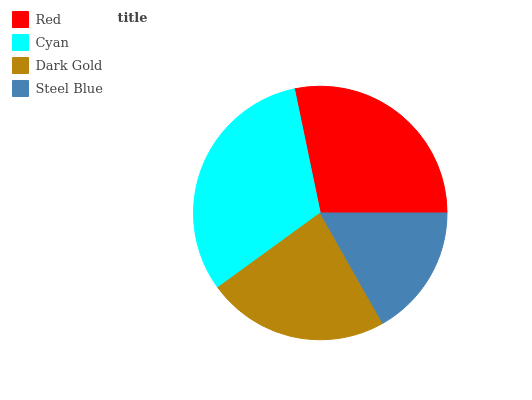Is Steel Blue the minimum?
Answer yes or no. Yes. Is Cyan the maximum?
Answer yes or no. Yes. Is Dark Gold the minimum?
Answer yes or no. No. Is Dark Gold the maximum?
Answer yes or no. No. Is Cyan greater than Dark Gold?
Answer yes or no. Yes. Is Dark Gold less than Cyan?
Answer yes or no. Yes. Is Dark Gold greater than Cyan?
Answer yes or no. No. Is Cyan less than Dark Gold?
Answer yes or no. No. Is Red the high median?
Answer yes or no. Yes. Is Dark Gold the low median?
Answer yes or no. Yes. Is Steel Blue the high median?
Answer yes or no. No. Is Steel Blue the low median?
Answer yes or no. No. 